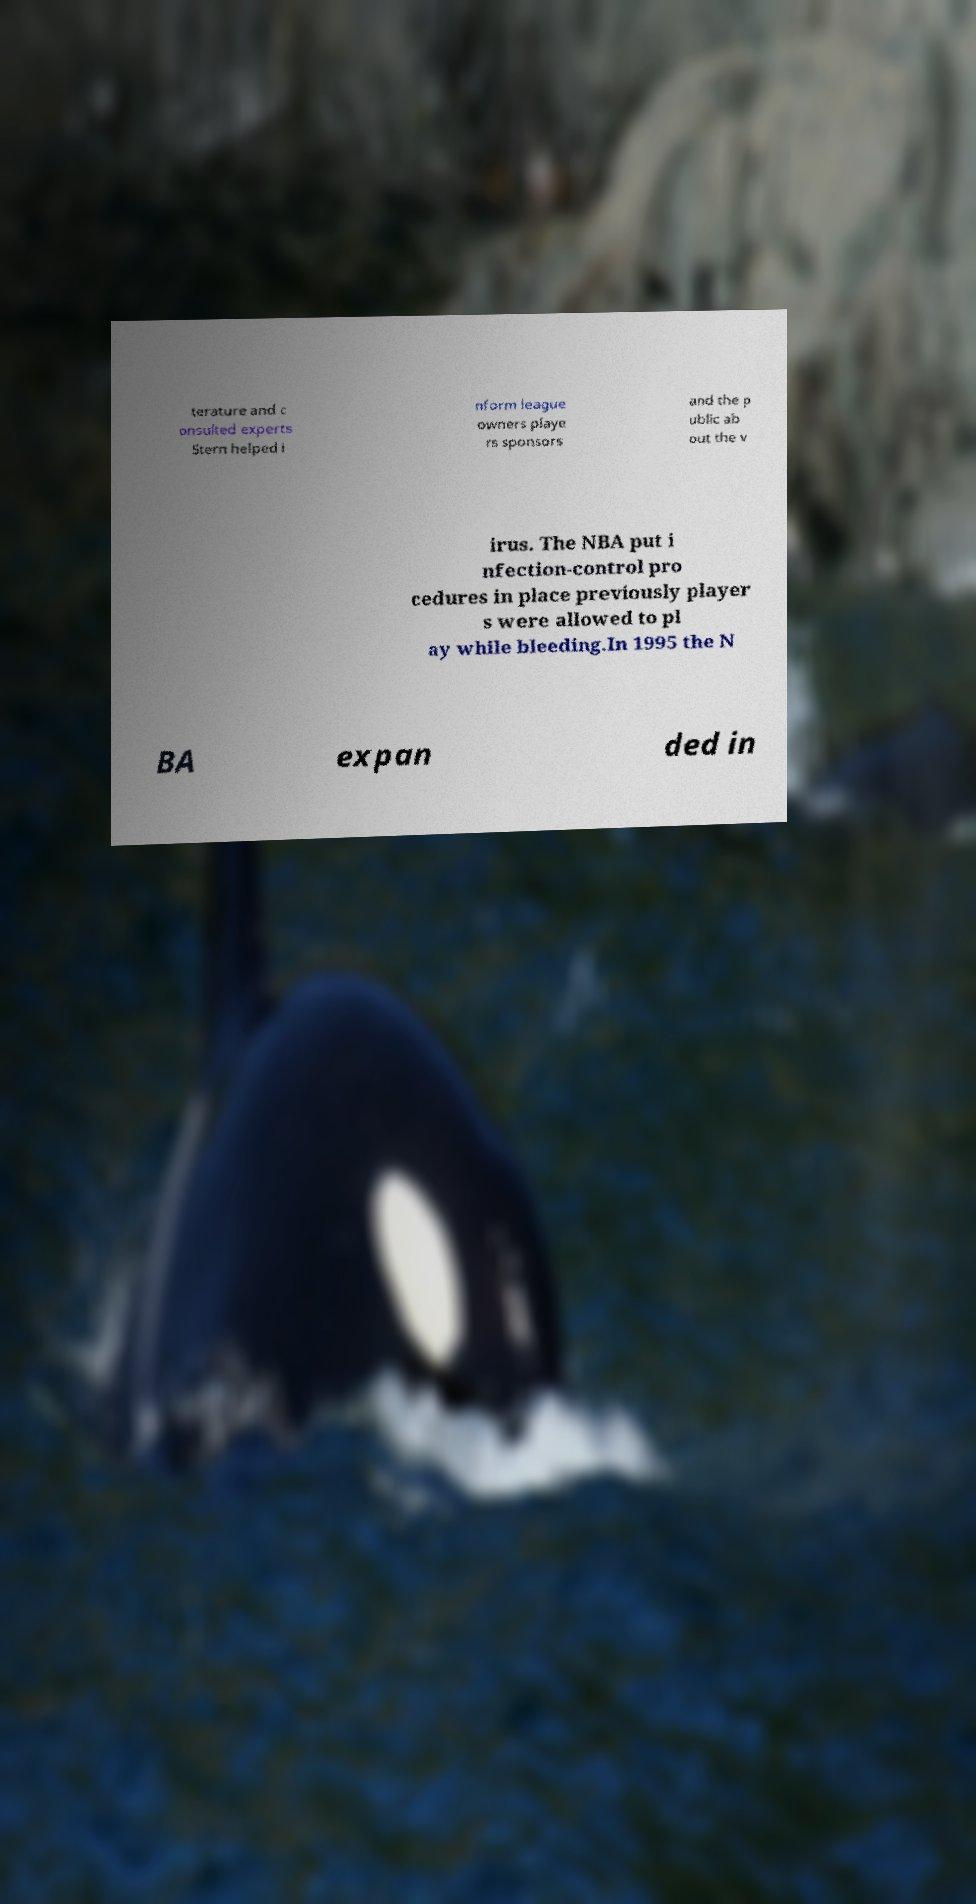Could you assist in decoding the text presented in this image and type it out clearly? terature and c onsulted experts Stern helped i nform league owners playe rs sponsors and the p ublic ab out the v irus. The NBA put i nfection-control pro cedures in place previously player s were allowed to pl ay while bleeding.In 1995 the N BA expan ded in 